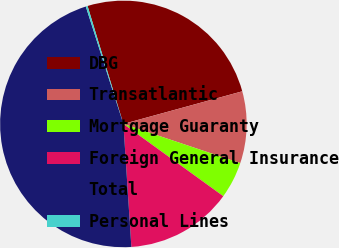<chart> <loc_0><loc_0><loc_500><loc_500><pie_chart><fcel>DBG<fcel>Transatlantic<fcel>Mortgage Guaranty<fcel>Foreign General Insurance<fcel>Total<fcel>Personal Lines<nl><fcel>25.43%<fcel>9.41%<fcel>4.82%<fcel>14.0%<fcel>46.1%<fcel>0.24%<nl></chart> 